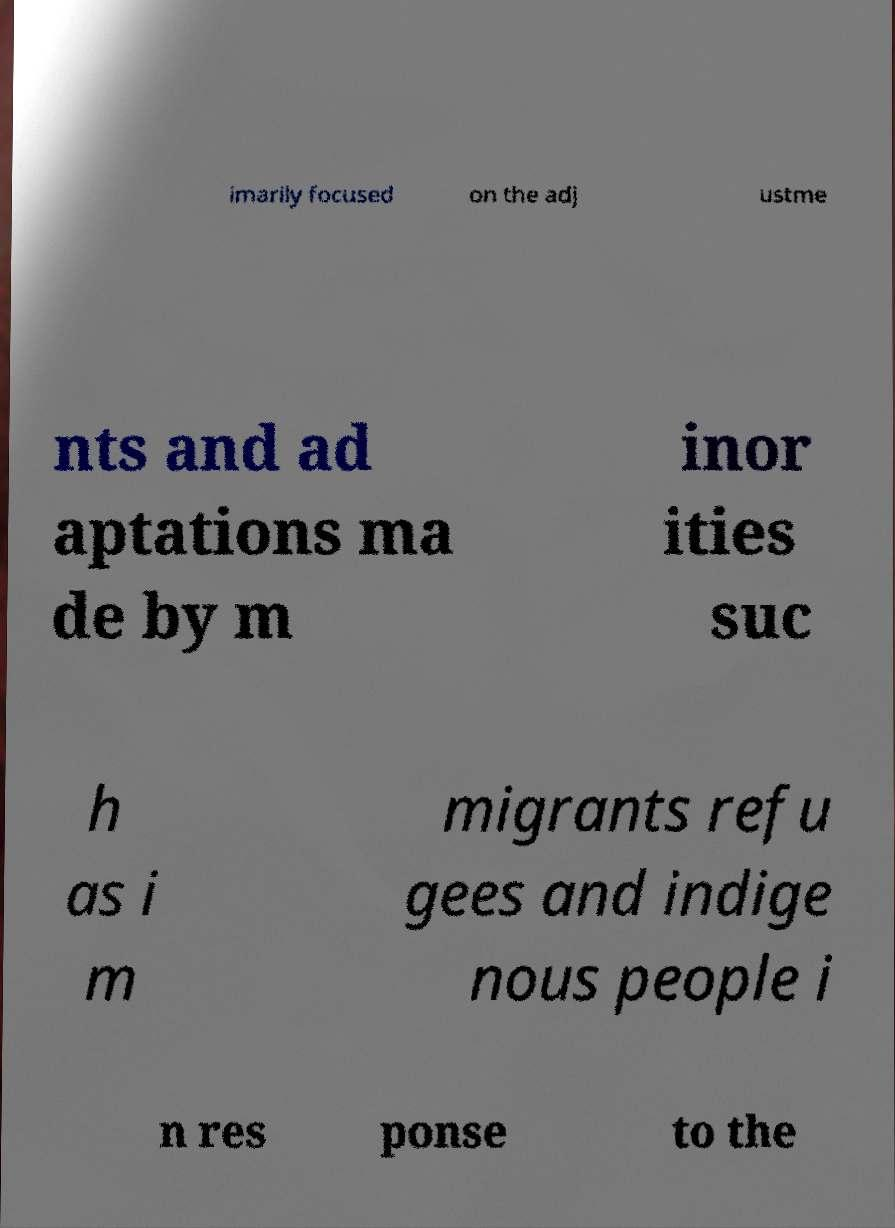Could you assist in decoding the text presented in this image and type it out clearly? imarily focused on the adj ustme nts and ad aptations ma de by m inor ities suc h as i m migrants refu gees and indige nous people i n res ponse to the 